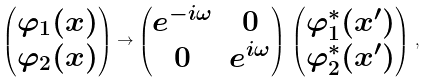<formula> <loc_0><loc_0><loc_500><loc_500>\begin{pmatrix} \varphi _ { 1 } ( x ) \\ \varphi _ { 2 } ( x ) \end{pmatrix} \rightarrow \begin{pmatrix} e ^ { - i \omega } & 0 \\ 0 & e ^ { i \omega } \end{pmatrix} \, \begin{pmatrix} \varphi _ { 1 } ^ { * } ( x ^ { \prime } ) \\ \varphi _ { 2 } ^ { * } ( x ^ { \prime } ) \end{pmatrix} \, ,</formula> 